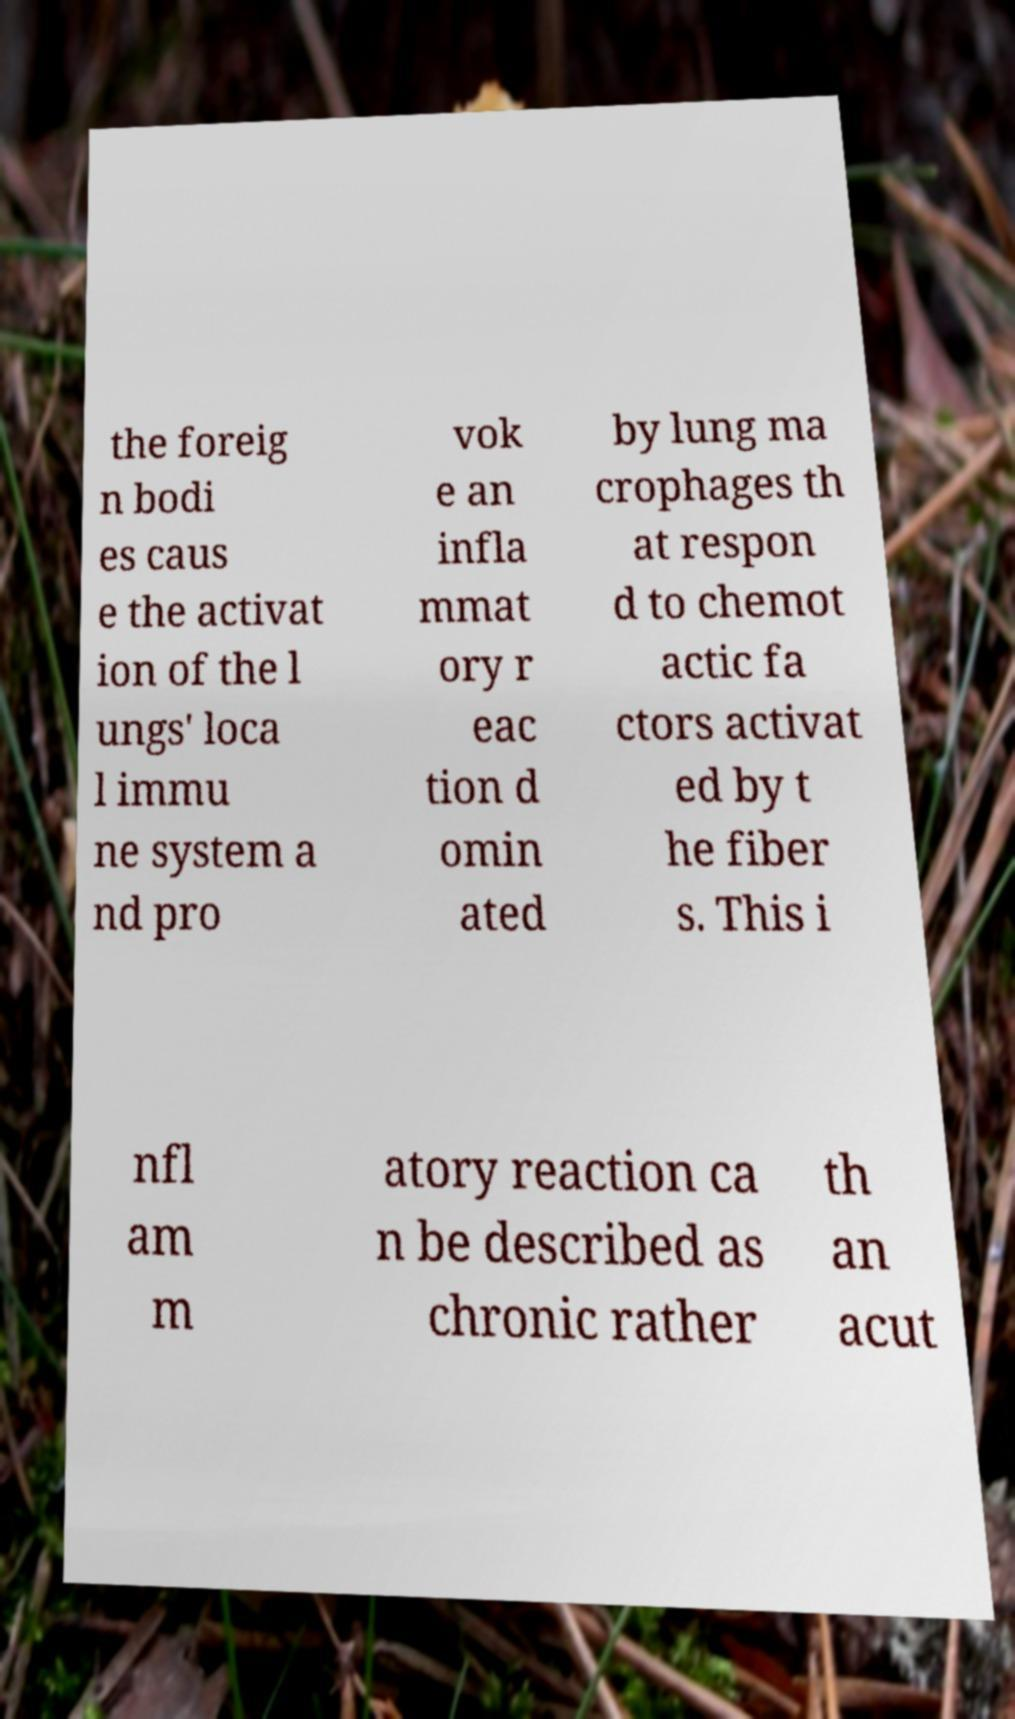For documentation purposes, I need the text within this image transcribed. Could you provide that? the foreig n bodi es caus e the activat ion of the l ungs' loca l immu ne system a nd pro vok e an infla mmat ory r eac tion d omin ated by lung ma crophages th at respon d to chemot actic fa ctors activat ed by t he fiber s. This i nfl am m atory reaction ca n be described as chronic rather th an acut 